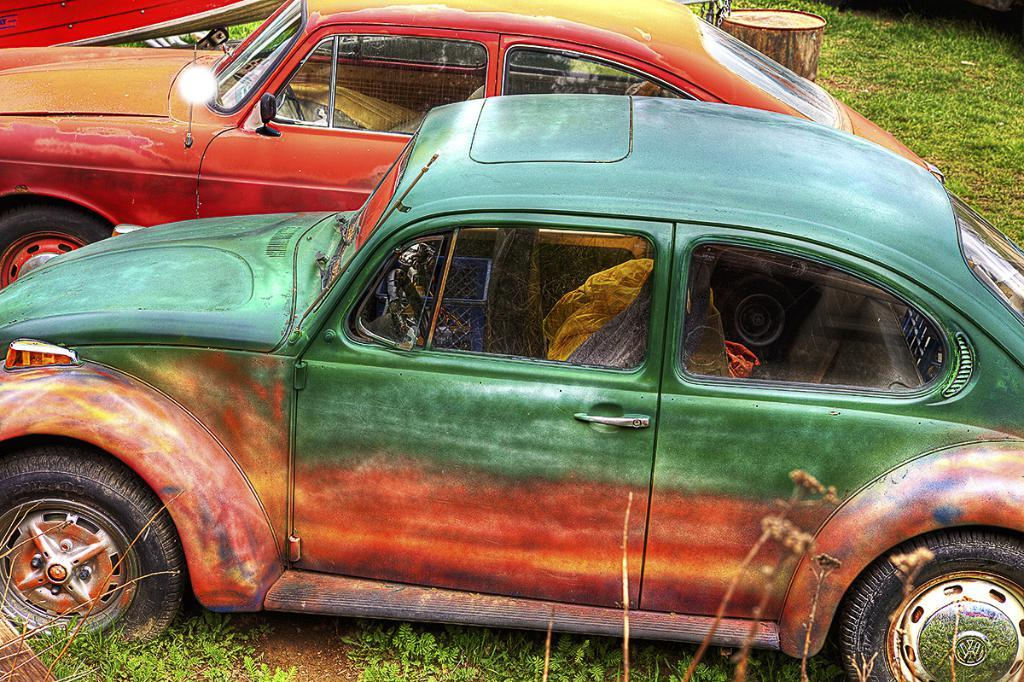What types of objects are present in the image? There are vehicles in the image. Can you describe the color of one of the vehicles? One of the vehicles is orange and green in color. What can be seen in the background of the image? The background of the image includes green grass. What type of pot is visible in the image? There is no pot present in the image. What kind of powder can be seen covering the vehicles in the image? There is no powder visible on the vehicles in the image. 